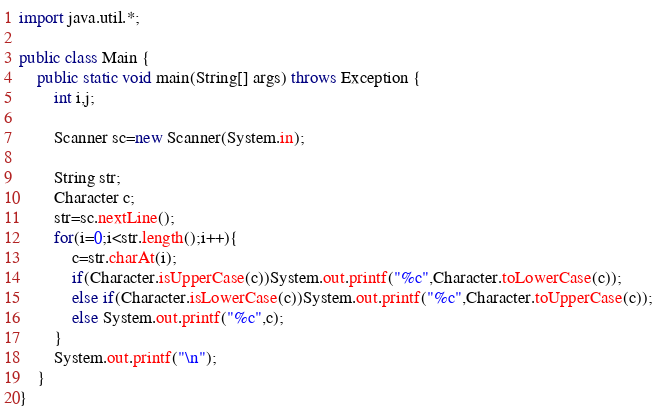<code> <loc_0><loc_0><loc_500><loc_500><_Java_>import java.util.*;

public class Main {
    public static void main(String[] args) throws Exception {
        int i,j;
        
        Scanner sc=new Scanner(System.in);
        
        String str;
        Character c;
        str=sc.nextLine();
        for(i=0;i<str.length();i++){
            c=str.charAt(i);
            if(Character.isUpperCase(c))System.out.printf("%c",Character.toLowerCase(c));
            else if(Character.isLowerCase(c))System.out.printf("%c",Character.toUpperCase(c));
            else System.out.printf("%c",c);
        }
        System.out.printf("\n");
    }
}

</code> 